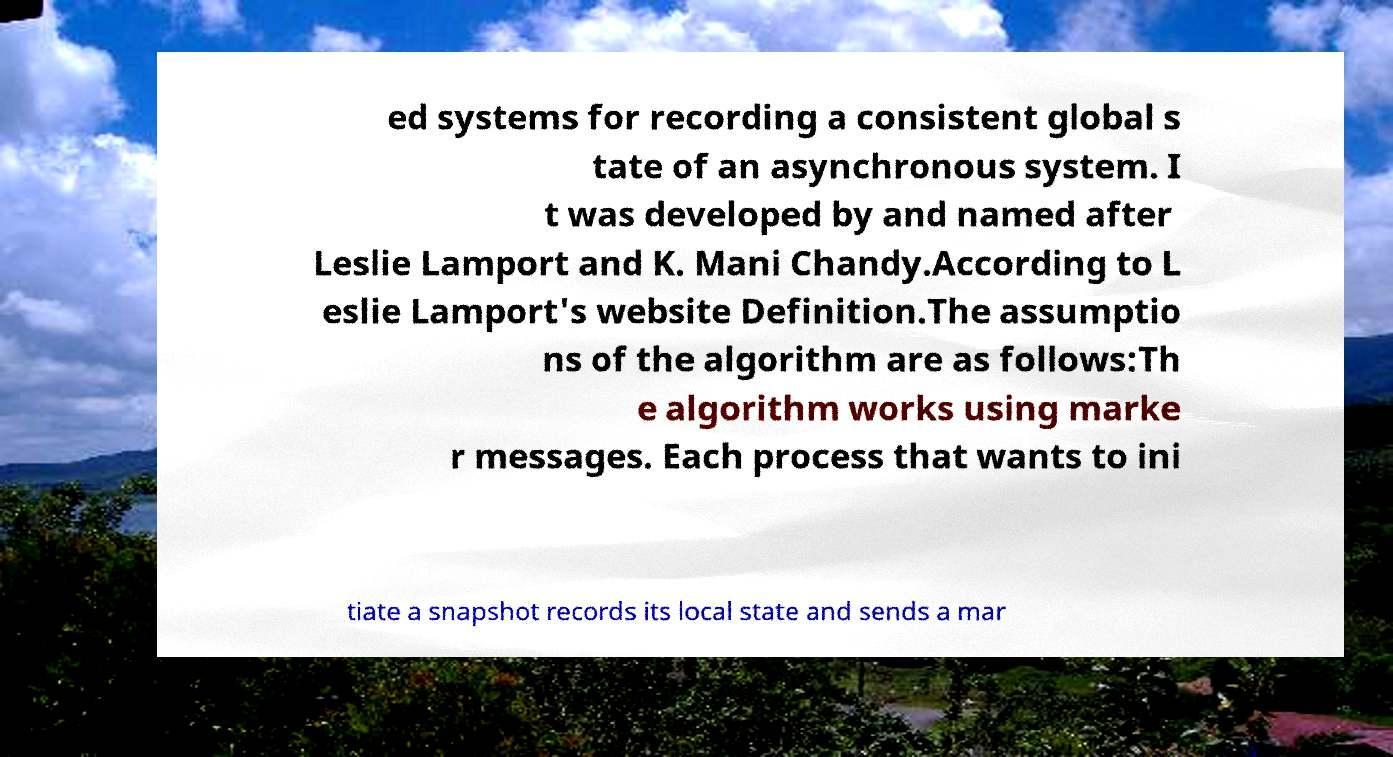Could you assist in decoding the text presented in this image and type it out clearly? ed systems for recording a consistent global s tate of an asynchronous system. I t was developed by and named after Leslie Lamport and K. Mani Chandy.According to L eslie Lamport's website Definition.The assumptio ns of the algorithm are as follows:Th e algorithm works using marke r messages. Each process that wants to ini tiate a snapshot records its local state and sends a mar 